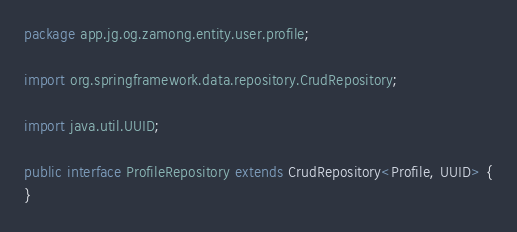<code> <loc_0><loc_0><loc_500><loc_500><_Java_>package app.jg.og.zamong.entity.user.profile;

import org.springframework.data.repository.CrudRepository;

import java.util.UUID;

public interface ProfileRepository extends CrudRepository<Profile, UUID> {
}
</code> 